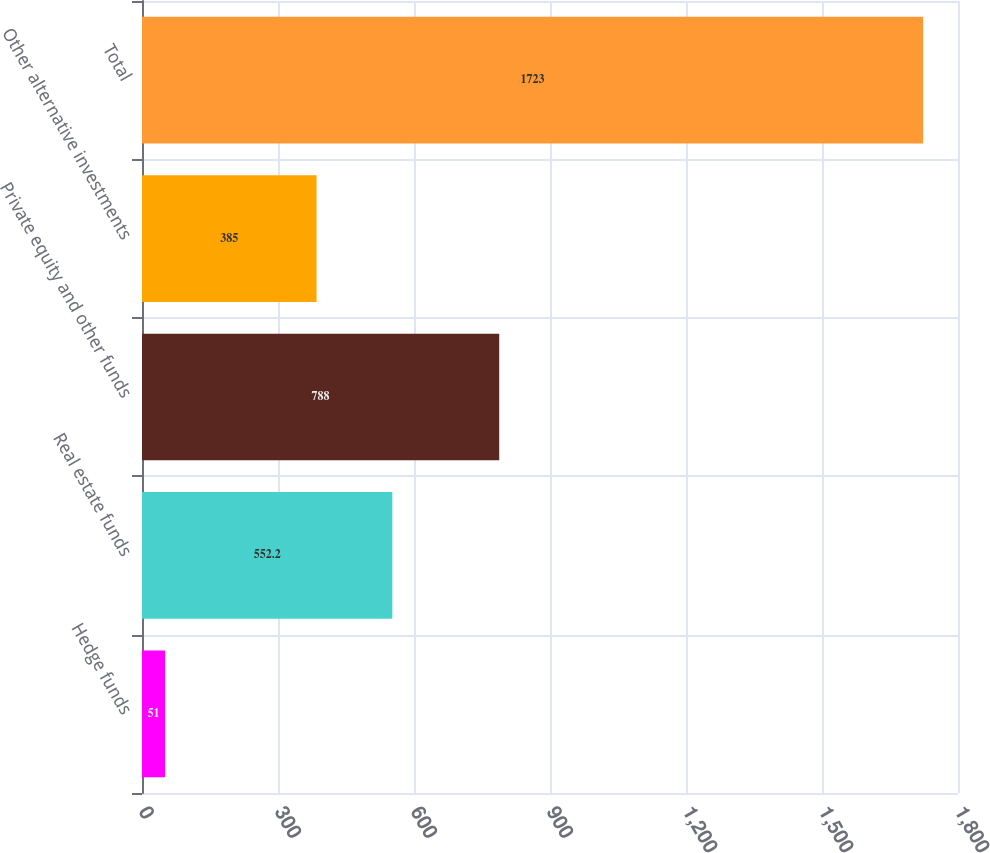Convert chart. <chart><loc_0><loc_0><loc_500><loc_500><bar_chart><fcel>Hedge funds<fcel>Real estate funds<fcel>Private equity and other funds<fcel>Other alternative investments<fcel>Total<nl><fcel>51<fcel>552.2<fcel>788<fcel>385<fcel>1723<nl></chart> 